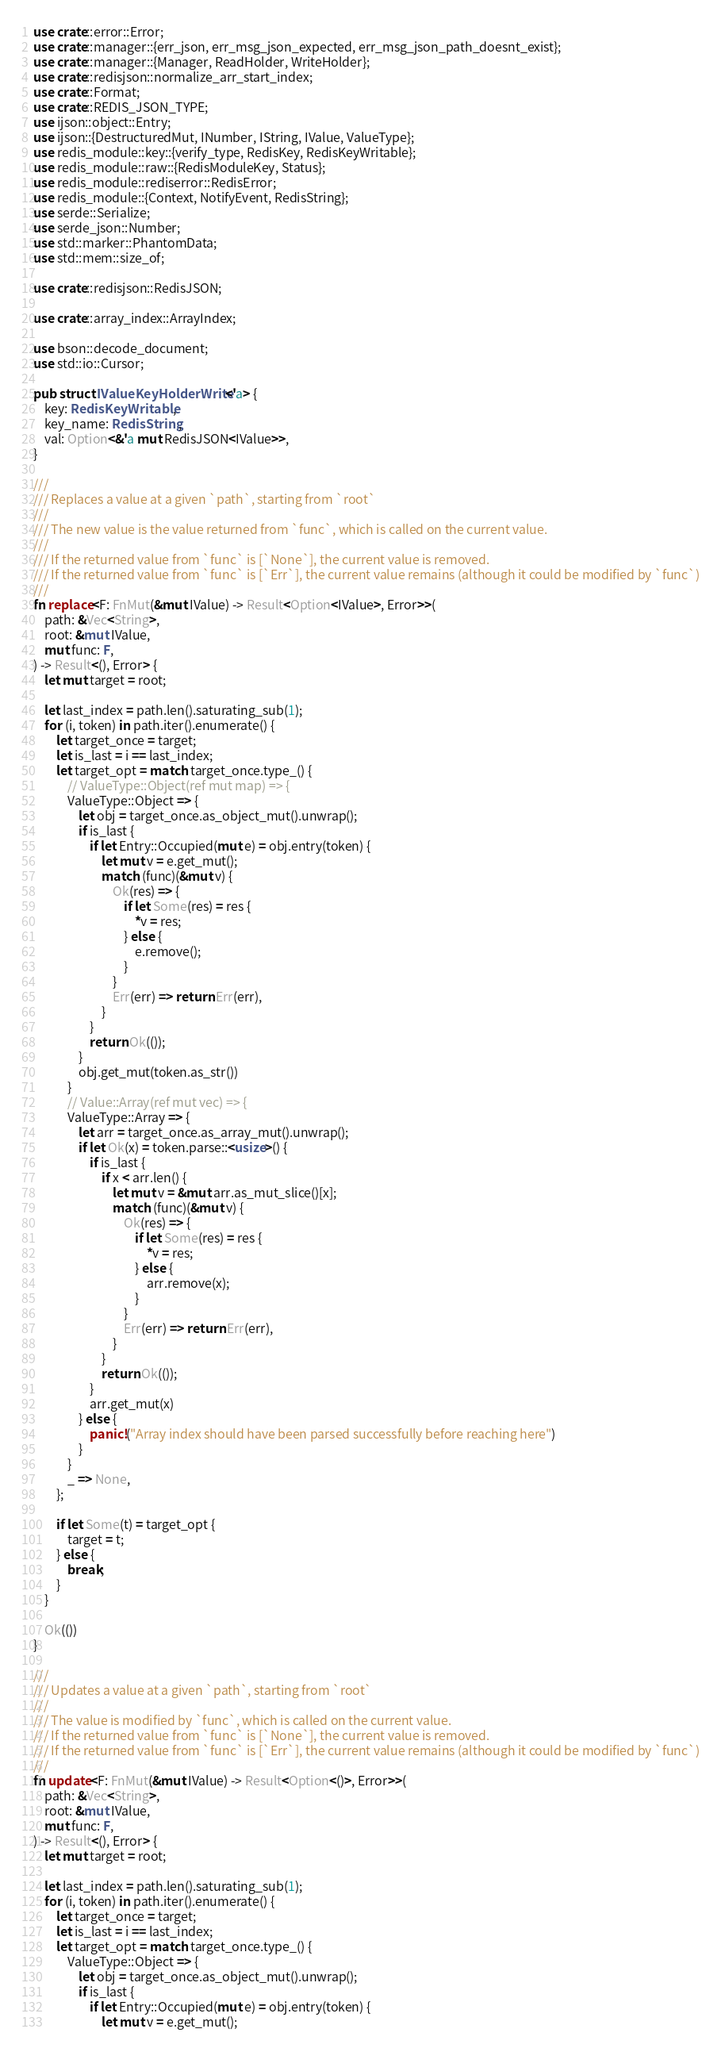Convert code to text. <code><loc_0><loc_0><loc_500><loc_500><_Rust_>use crate::error::Error;
use crate::manager::{err_json, err_msg_json_expected, err_msg_json_path_doesnt_exist};
use crate::manager::{Manager, ReadHolder, WriteHolder};
use crate::redisjson::normalize_arr_start_index;
use crate::Format;
use crate::REDIS_JSON_TYPE;
use ijson::object::Entry;
use ijson::{DestructuredMut, INumber, IString, IValue, ValueType};
use redis_module::key::{verify_type, RedisKey, RedisKeyWritable};
use redis_module::raw::{RedisModuleKey, Status};
use redis_module::rediserror::RedisError;
use redis_module::{Context, NotifyEvent, RedisString};
use serde::Serialize;
use serde_json::Number;
use std::marker::PhantomData;
use std::mem::size_of;

use crate::redisjson::RedisJSON;

use crate::array_index::ArrayIndex;

use bson::decode_document;
use std::io::Cursor;

pub struct IValueKeyHolderWrite<'a> {
    key: RedisKeyWritable,
    key_name: RedisString,
    val: Option<&'a mut RedisJSON<IValue>>,
}

///
/// Replaces a value at a given `path`, starting from `root`
///
/// The new value is the value returned from `func`, which is called on the current value.
///
/// If the returned value from `func` is [`None`], the current value is removed.
/// If the returned value from `func` is [`Err`], the current value remains (although it could be modified by `func`)
///
fn replace<F: FnMut(&mut IValue) -> Result<Option<IValue>, Error>>(
    path: &Vec<String>,
    root: &mut IValue,
    mut func: F,
) -> Result<(), Error> {
    let mut target = root;

    let last_index = path.len().saturating_sub(1);
    for (i, token) in path.iter().enumerate() {
        let target_once = target;
        let is_last = i == last_index;
        let target_opt = match target_once.type_() {
            // ValueType::Object(ref mut map) => {
            ValueType::Object => {
                let obj = target_once.as_object_mut().unwrap();
                if is_last {
                    if let Entry::Occupied(mut e) = obj.entry(token) {
                        let mut v = e.get_mut();
                        match (func)(&mut v) {
                            Ok(res) => {
                                if let Some(res) = res {
                                    *v = res;
                                } else {
                                    e.remove();
                                }
                            }
                            Err(err) => return Err(err),
                        }
                    }
                    return Ok(());
                }
                obj.get_mut(token.as_str())
            }
            // Value::Array(ref mut vec) => {
            ValueType::Array => {
                let arr = target_once.as_array_mut().unwrap();
                if let Ok(x) = token.parse::<usize>() {
                    if is_last {
                        if x < arr.len() {
                            let mut v = &mut arr.as_mut_slice()[x];
                            match (func)(&mut v) {
                                Ok(res) => {
                                    if let Some(res) = res {
                                        *v = res;
                                    } else {
                                        arr.remove(x);
                                    }
                                }
                                Err(err) => return Err(err),
                            }
                        }
                        return Ok(());
                    }
                    arr.get_mut(x)
                } else {
                    panic!("Array index should have been parsed successfully before reaching here")
                }
            }
            _ => None,
        };

        if let Some(t) = target_opt {
            target = t;
        } else {
            break;
        }
    }

    Ok(())
}

///
/// Updates a value at a given `path`, starting from `root`
///
/// The value is modified by `func`, which is called on the current value.
/// If the returned value from `func` is [`None`], the current value is removed.
/// If the returned value from `func` is [`Err`], the current value remains (although it could be modified by `func`)
///
fn update<F: FnMut(&mut IValue) -> Result<Option<()>, Error>>(
    path: &Vec<String>,
    root: &mut IValue,
    mut func: F,
) -> Result<(), Error> {
    let mut target = root;

    let last_index = path.len().saturating_sub(1);
    for (i, token) in path.iter().enumerate() {
        let target_once = target;
        let is_last = i == last_index;
        let target_opt = match target_once.type_() {
            ValueType::Object => {
                let obj = target_once.as_object_mut().unwrap();
                if is_last {
                    if let Entry::Occupied(mut e) = obj.entry(token) {
                        let mut v = e.get_mut();</code> 